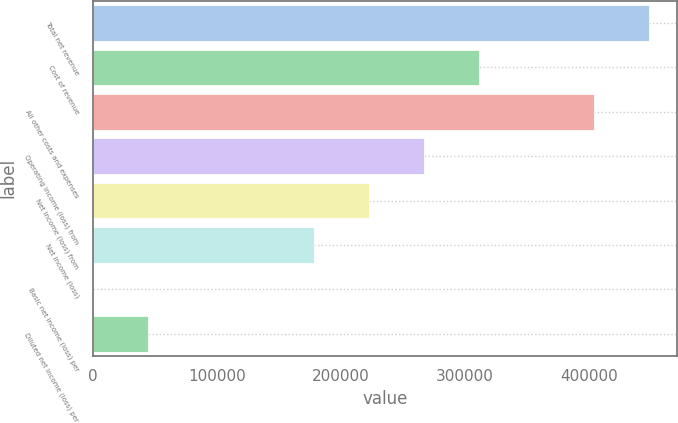<chart> <loc_0><loc_0><loc_500><loc_500><bar_chart><fcel>Total net revenue<fcel>Cost of revenue<fcel>All other costs and expenses<fcel>Operating income (loss) from<fcel>Net income (loss) from<fcel>Net income (loss)<fcel>Basic net income (loss) per<fcel>Diluted net income (loss) per<nl><fcel>448616<fcel>311457<fcel>404122<fcel>266963<fcel>222469<fcel>177975<fcel>0.06<fcel>44493.8<nl></chart> 